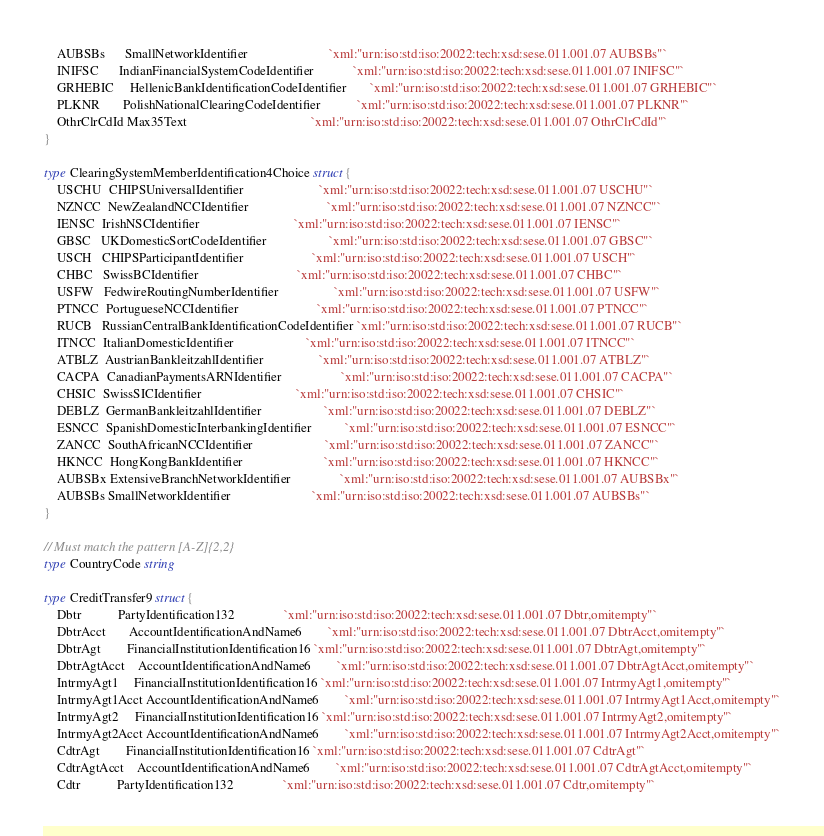Convert code to text. <code><loc_0><loc_0><loc_500><loc_500><_Go_>	AUBSBs      SmallNetworkIdentifier                         `xml:"urn:iso:std:iso:20022:tech:xsd:sese.011.001.07 AUBSBs"`
	INIFSC      IndianFinancialSystemCodeIdentifier            `xml:"urn:iso:std:iso:20022:tech:xsd:sese.011.001.07 INIFSC"`
	GRHEBIC     HellenicBankIdentificationCodeIdentifier       `xml:"urn:iso:std:iso:20022:tech:xsd:sese.011.001.07 GRHEBIC"`
	PLKNR       PolishNationalClearingCodeIdentifier           `xml:"urn:iso:std:iso:20022:tech:xsd:sese.011.001.07 PLKNR"`
	OthrClrCdId Max35Text                                      `xml:"urn:iso:std:iso:20022:tech:xsd:sese.011.001.07 OthrClrCdId"`
}

type ClearingSystemMemberIdentification4Choice struct {
	USCHU  CHIPSUniversalIdentifier                       `xml:"urn:iso:std:iso:20022:tech:xsd:sese.011.001.07 USCHU"`
	NZNCC  NewZealandNCCIdentifier                        `xml:"urn:iso:std:iso:20022:tech:xsd:sese.011.001.07 NZNCC"`
	IENSC  IrishNSCIdentifier                             `xml:"urn:iso:std:iso:20022:tech:xsd:sese.011.001.07 IENSC"`
	GBSC   UKDomesticSortCodeIdentifier                   `xml:"urn:iso:std:iso:20022:tech:xsd:sese.011.001.07 GBSC"`
	USCH   CHIPSParticipantIdentifier                     `xml:"urn:iso:std:iso:20022:tech:xsd:sese.011.001.07 USCH"`
	CHBC   SwissBCIdentifier                              `xml:"urn:iso:std:iso:20022:tech:xsd:sese.011.001.07 CHBC"`
	USFW   FedwireRoutingNumberIdentifier                 `xml:"urn:iso:std:iso:20022:tech:xsd:sese.011.001.07 USFW"`
	PTNCC  PortugueseNCCIdentifier                        `xml:"urn:iso:std:iso:20022:tech:xsd:sese.011.001.07 PTNCC"`
	RUCB   RussianCentralBankIdentificationCodeIdentifier `xml:"urn:iso:std:iso:20022:tech:xsd:sese.011.001.07 RUCB"`
	ITNCC  ItalianDomesticIdentifier                      `xml:"urn:iso:std:iso:20022:tech:xsd:sese.011.001.07 ITNCC"`
	ATBLZ  AustrianBankleitzahlIdentifier                 `xml:"urn:iso:std:iso:20022:tech:xsd:sese.011.001.07 ATBLZ"`
	CACPA  CanadianPaymentsARNIdentifier                  `xml:"urn:iso:std:iso:20022:tech:xsd:sese.011.001.07 CACPA"`
	CHSIC  SwissSICIdentifier                             `xml:"urn:iso:std:iso:20022:tech:xsd:sese.011.001.07 CHSIC"`
	DEBLZ  GermanBankleitzahlIdentifier                   `xml:"urn:iso:std:iso:20022:tech:xsd:sese.011.001.07 DEBLZ"`
	ESNCC  SpanishDomesticInterbankingIdentifier          `xml:"urn:iso:std:iso:20022:tech:xsd:sese.011.001.07 ESNCC"`
	ZANCC  SouthAfricanNCCIdentifier                      `xml:"urn:iso:std:iso:20022:tech:xsd:sese.011.001.07 ZANCC"`
	HKNCC  HongKongBankIdentifier                         `xml:"urn:iso:std:iso:20022:tech:xsd:sese.011.001.07 HKNCC"`
	AUBSBx ExtensiveBranchNetworkIdentifier               `xml:"urn:iso:std:iso:20022:tech:xsd:sese.011.001.07 AUBSBx"`
	AUBSBs SmallNetworkIdentifier                         `xml:"urn:iso:std:iso:20022:tech:xsd:sese.011.001.07 AUBSBs"`
}

// Must match the pattern [A-Z]{2,2}
type CountryCode string

type CreditTransfer9 struct {
	Dbtr           PartyIdentification132               `xml:"urn:iso:std:iso:20022:tech:xsd:sese.011.001.07 Dbtr,omitempty"`
	DbtrAcct       AccountIdentificationAndName6        `xml:"urn:iso:std:iso:20022:tech:xsd:sese.011.001.07 DbtrAcct,omitempty"`
	DbtrAgt        FinancialInstitutionIdentification16 `xml:"urn:iso:std:iso:20022:tech:xsd:sese.011.001.07 DbtrAgt,omitempty"`
	DbtrAgtAcct    AccountIdentificationAndName6        `xml:"urn:iso:std:iso:20022:tech:xsd:sese.011.001.07 DbtrAgtAcct,omitempty"`
	IntrmyAgt1     FinancialInstitutionIdentification16 `xml:"urn:iso:std:iso:20022:tech:xsd:sese.011.001.07 IntrmyAgt1,omitempty"`
	IntrmyAgt1Acct AccountIdentificationAndName6        `xml:"urn:iso:std:iso:20022:tech:xsd:sese.011.001.07 IntrmyAgt1Acct,omitempty"`
	IntrmyAgt2     FinancialInstitutionIdentification16 `xml:"urn:iso:std:iso:20022:tech:xsd:sese.011.001.07 IntrmyAgt2,omitempty"`
	IntrmyAgt2Acct AccountIdentificationAndName6        `xml:"urn:iso:std:iso:20022:tech:xsd:sese.011.001.07 IntrmyAgt2Acct,omitempty"`
	CdtrAgt        FinancialInstitutionIdentification16 `xml:"urn:iso:std:iso:20022:tech:xsd:sese.011.001.07 CdtrAgt"`
	CdtrAgtAcct    AccountIdentificationAndName6        `xml:"urn:iso:std:iso:20022:tech:xsd:sese.011.001.07 CdtrAgtAcct,omitempty"`
	Cdtr           PartyIdentification132               `xml:"urn:iso:std:iso:20022:tech:xsd:sese.011.001.07 Cdtr,omitempty"`</code> 